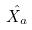Convert formula to latex. <formula><loc_0><loc_0><loc_500><loc_500>\hat { X _ { a } }</formula> 